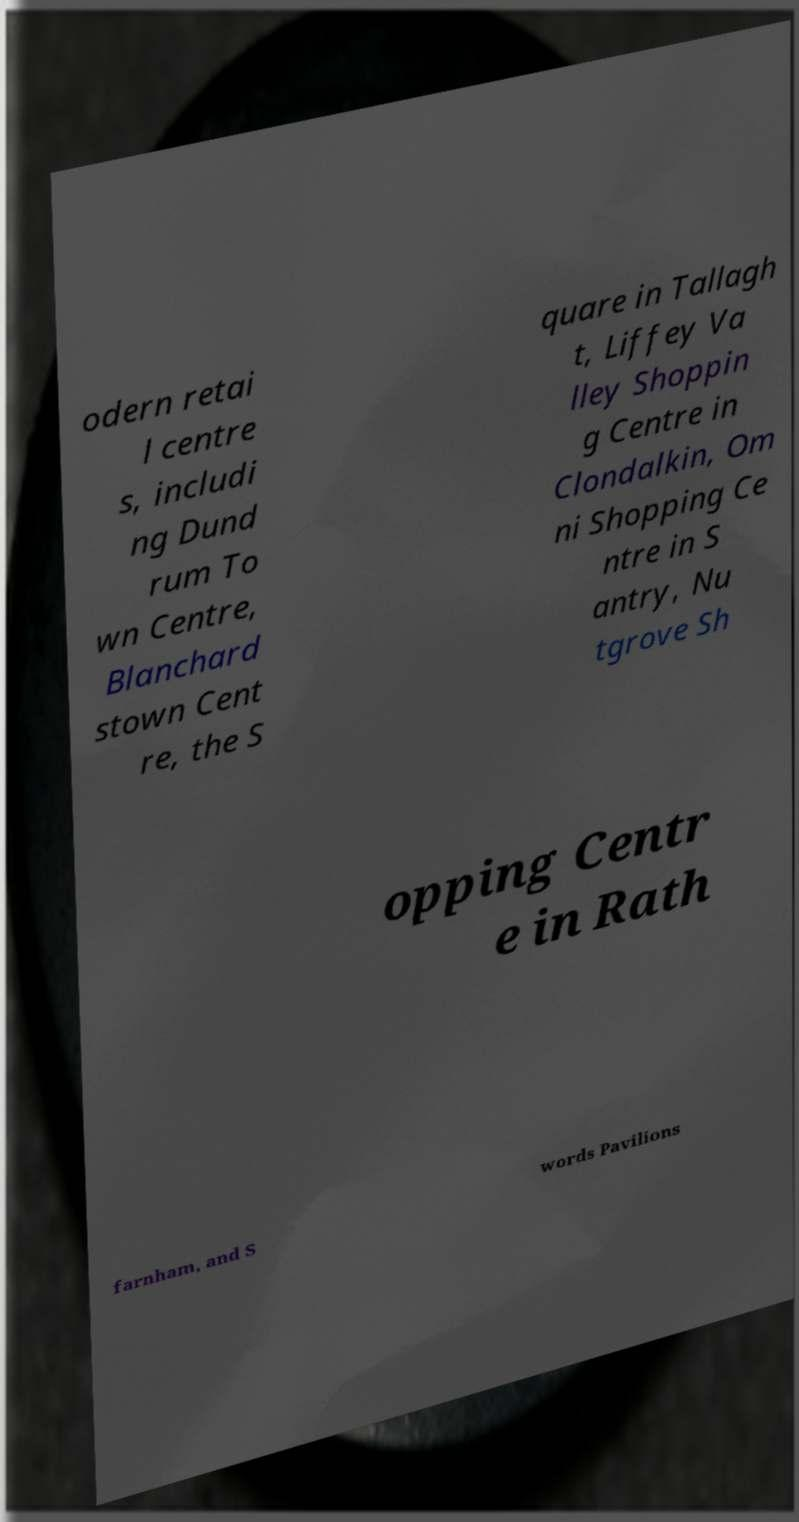Please read and relay the text visible in this image. What does it say? odern retai l centre s, includi ng Dund rum To wn Centre, Blanchard stown Cent re, the S quare in Tallagh t, Liffey Va lley Shoppin g Centre in Clondalkin, Om ni Shopping Ce ntre in S antry, Nu tgrove Sh opping Centr e in Rath farnham, and S words Pavilions 